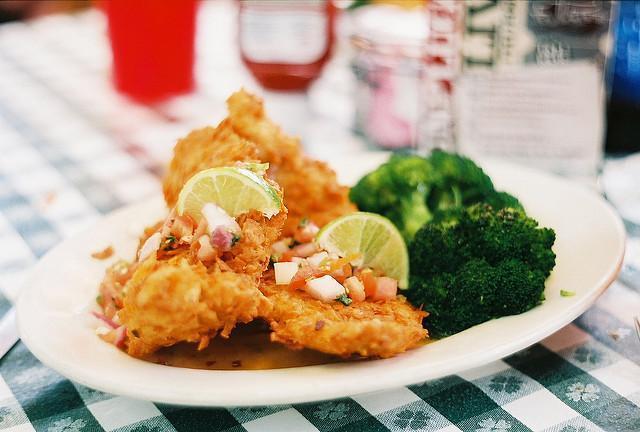How many bottles are in the picture?
Give a very brief answer. 1. How many broccolis are visible?
Give a very brief answer. 2. How many dining tables are in the picture?
Give a very brief answer. 1. 